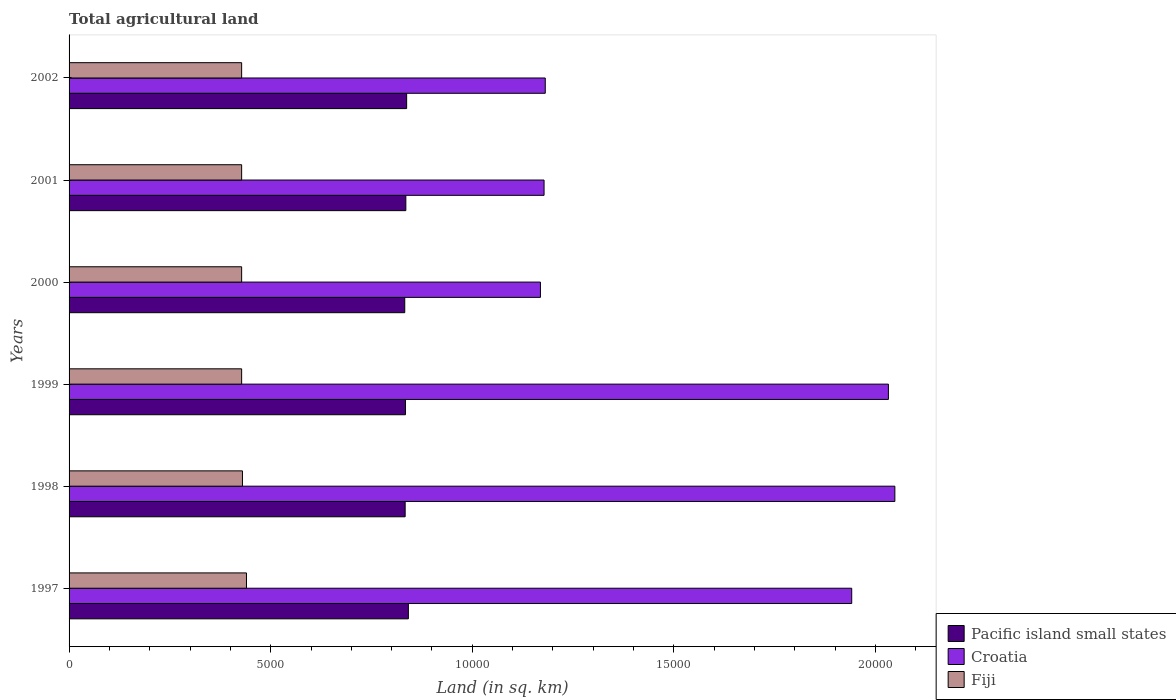How many different coloured bars are there?
Keep it short and to the point. 3. How many groups of bars are there?
Provide a succinct answer. 6. Are the number of bars per tick equal to the number of legend labels?
Make the answer very short. Yes. How many bars are there on the 4th tick from the top?
Your response must be concise. 3. In how many cases, is the number of bars for a given year not equal to the number of legend labels?
Provide a short and direct response. 0. What is the total agricultural land in Fiji in 2002?
Provide a short and direct response. 4280. Across all years, what is the maximum total agricultural land in Fiji?
Your answer should be very brief. 4400. Across all years, what is the minimum total agricultural land in Fiji?
Provide a short and direct response. 4280. What is the total total agricultural land in Croatia in the graph?
Offer a very short reply. 9.55e+04. What is the difference between the total agricultural land in Fiji in 1998 and that in 2001?
Keep it short and to the point. 20. What is the difference between the total agricultural land in Croatia in 2000 and the total agricultural land in Fiji in 2002?
Ensure brevity in your answer.  7410. What is the average total agricultural land in Fiji per year?
Offer a terse response. 4303.33. In the year 1997, what is the difference between the total agricultural land in Fiji and total agricultural land in Pacific island small states?
Provide a short and direct response. -4015. What is the ratio of the total agricultural land in Croatia in 1999 to that in 2001?
Give a very brief answer. 1.72. What is the difference between the highest and the lowest total agricultural land in Pacific island small states?
Keep it short and to the point. 90. What does the 3rd bar from the top in 2000 represents?
Offer a terse response. Pacific island small states. What does the 1st bar from the bottom in 1997 represents?
Keep it short and to the point. Pacific island small states. Is it the case that in every year, the sum of the total agricultural land in Fiji and total agricultural land in Pacific island small states is greater than the total agricultural land in Croatia?
Your answer should be very brief. No. How many years are there in the graph?
Ensure brevity in your answer.  6. What is the difference between two consecutive major ticks on the X-axis?
Ensure brevity in your answer.  5000. Are the values on the major ticks of X-axis written in scientific E-notation?
Your answer should be very brief. No. Does the graph contain any zero values?
Offer a terse response. No. Where does the legend appear in the graph?
Your answer should be very brief. Bottom right. How many legend labels are there?
Provide a short and direct response. 3. How are the legend labels stacked?
Offer a very short reply. Vertical. What is the title of the graph?
Offer a terse response. Total agricultural land. What is the label or title of the X-axis?
Your response must be concise. Land (in sq. km). What is the Land (in sq. km) in Pacific island small states in 1997?
Provide a succinct answer. 8415. What is the Land (in sq. km) of Croatia in 1997?
Provide a succinct answer. 1.94e+04. What is the Land (in sq. km) of Fiji in 1997?
Make the answer very short. 4400. What is the Land (in sq. km) in Pacific island small states in 1998?
Offer a terse response. 8335. What is the Land (in sq. km) of Croatia in 1998?
Offer a terse response. 2.05e+04. What is the Land (in sq. km) of Fiji in 1998?
Your answer should be very brief. 4300. What is the Land (in sq. km) of Pacific island small states in 1999?
Keep it short and to the point. 8343. What is the Land (in sq. km) in Croatia in 1999?
Provide a succinct answer. 2.03e+04. What is the Land (in sq. km) in Fiji in 1999?
Offer a terse response. 4280. What is the Land (in sq. km) in Pacific island small states in 2000?
Give a very brief answer. 8325. What is the Land (in sq. km) of Croatia in 2000?
Make the answer very short. 1.17e+04. What is the Land (in sq. km) in Fiji in 2000?
Give a very brief answer. 4280. What is the Land (in sq. km) of Pacific island small states in 2001?
Provide a succinct answer. 8352. What is the Land (in sq. km) in Croatia in 2001?
Provide a succinct answer. 1.18e+04. What is the Land (in sq. km) of Fiji in 2001?
Ensure brevity in your answer.  4280. What is the Land (in sq. km) in Pacific island small states in 2002?
Your response must be concise. 8372. What is the Land (in sq. km) in Croatia in 2002?
Offer a very short reply. 1.18e+04. What is the Land (in sq. km) of Fiji in 2002?
Provide a short and direct response. 4280. Across all years, what is the maximum Land (in sq. km) of Pacific island small states?
Ensure brevity in your answer.  8415. Across all years, what is the maximum Land (in sq. km) of Croatia?
Your answer should be compact. 2.05e+04. Across all years, what is the maximum Land (in sq. km) of Fiji?
Offer a terse response. 4400. Across all years, what is the minimum Land (in sq. km) in Pacific island small states?
Your response must be concise. 8325. Across all years, what is the minimum Land (in sq. km) of Croatia?
Offer a terse response. 1.17e+04. Across all years, what is the minimum Land (in sq. km) in Fiji?
Keep it short and to the point. 4280. What is the total Land (in sq. km) in Pacific island small states in the graph?
Keep it short and to the point. 5.01e+04. What is the total Land (in sq. km) of Croatia in the graph?
Keep it short and to the point. 9.55e+04. What is the total Land (in sq. km) in Fiji in the graph?
Give a very brief answer. 2.58e+04. What is the difference between the Land (in sq. km) of Croatia in 1997 and that in 1998?
Provide a succinct answer. -1070. What is the difference between the Land (in sq. km) in Pacific island small states in 1997 and that in 1999?
Give a very brief answer. 72. What is the difference between the Land (in sq. km) of Croatia in 1997 and that in 1999?
Your response must be concise. -910. What is the difference between the Land (in sq. km) in Fiji in 1997 and that in 1999?
Provide a short and direct response. 120. What is the difference between the Land (in sq. km) of Croatia in 1997 and that in 2000?
Offer a very short reply. 7720. What is the difference between the Land (in sq. km) of Fiji in 1997 and that in 2000?
Keep it short and to the point. 120. What is the difference between the Land (in sq. km) of Croatia in 1997 and that in 2001?
Your response must be concise. 7630. What is the difference between the Land (in sq. km) of Fiji in 1997 and that in 2001?
Provide a succinct answer. 120. What is the difference between the Land (in sq. km) in Croatia in 1997 and that in 2002?
Offer a very short reply. 7600. What is the difference between the Land (in sq. km) of Fiji in 1997 and that in 2002?
Offer a terse response. 120. What is the difference between the Land (in sq. km) in Croatia in 1998 and that in 1999?
Keep it short and to the point. 160. What is the difference between the Land (in sq. km) in Fiji in 1998 and that in 1999?
Give a very brief answer. 20. What is the difference between the Land (in sq. km) of Pacific island small states in 1998 and that in 2000?
Ensure brevity in your answer.  10. What is the difference between the Land (in sq. km) of Croatia in 1998 and that in 2000?
Your answer should be very brief. 8790. What is the difference between the Land (in sq. km) of Croatia in 1998 and that in 2001?
Provide a short and direct response. 8700. What is the difference between the Land (in sq. km) in Pacific island small states in 1998 and that in 2002?
Keep it short and to the point. -37. What is the difference between the Land (in sq. km) of Croatia in 1998 and that in 2002?
Provide a short and direct response. 8670. What is the difference between the Land (in sq. km) in Pacific island small states in 1999 and that in 2000?
Your answer should be very brief. 18. What is the difference between the Land (in sq. km) in Croatia in 1999 and that in 2000?
Keep it short and to the point. 8630. What is the difference between the Land (in sq. km) in Croatia in 1999 and that in 2001?
Your answer should be compact. 8540. What is the difference between the Land (in sq. km) in Pacific island small states in 1999 and that in 2002?
Offer a terse response. -29. What is the difference between the Land (in sq. km) in Croatia in 1999 and that in 2002?
Your answer should be very brief. 8510. What is the difference between the Land (in sq. km) of Croatia in 2000 and that in 2001?
Offer a terse response. -90. What is the difference between the Land (in sq. km) of Fiji in 2000 and that in 2001?
Offer a terse response. 0. What is the difference between the Land (in sq. km) of Pacific island small states in 2000 and that in 2002?
Your answer should be very brief. -47. What is the difference between the Land (in sq. km) of Croatia in 2000 and that in 2002?
Your answer should be compact. -120. What is the difference between the Land (in sq. km) of Fiji in 2000 and that in 2002?
Give a very brief answer. 0. What is the difference between the Land (in sq. km) of Pacific island small states in 2001 and that in 2002?
Offer a terse response. -20. What is the difference between the Land (in sq. km) in Croatia in 2001 and that in 2002?
Your response must be concise. -30. What is the difference between the Land (in sq. km) of Fiji in 2001 and that in 2002?
Your answer should be compact. 0. What is the difference between the Land (in sq. km) of Pacific island small states in 1997 and the Land (in sq. km) of Croatia in 1998?
Keep it short and to the point. -1.21e+04. What is the difference between the Land (in sq. km) of Pacific island small states in 1997 and the Land (in sq. km) of Fiji in 1998?
Keep it short and to the point. 4115. What is the difference between the Land (in sq. km) of Croatia in 1997 and the Land (in sq. km) of Fiji in 1998?
Provide a succinct answer. 1.51e+04. What is the difference between the Land (in sq. km) of Pacific island small states in 1997 and the Land (in sq. km) of Croatia in 1999?
Keep it short and to the point. -1.19e+04. What is the difference between the Land (in sq. km) of Pacific island small states in 1997 and the Land (in sq. km) of Fiji in 1999?
Offer a very short reply. 4135. What is the difference between the Land (in sq. km) of Croatia in 1997 and the Land (in sq. km) of Fiji in 1999?
Make the answer very short. 1.51e+04. What is the difference between the Land (in sq. km) in Pacific island small states in 1997 and the Land (in sq. km) in Croatia in 2000?
Keep it short and to the point. -3275. What is the difference between the Land (in sq. km) of Pacific island small states in 1997 and the Land (in sq. km) of Fiji in 2000?
Provide a succinct answer. 4135. What is the difference between the Land (in sq. km) in Croatia in 1997 and the Land (in sq. km) in Fiji in 2000?
Ensure brevity in your answer.  1.51e+04. What is the difference between the Land (in sq. km) of Pacific island small states in 1997 and the Land (in sq. km) of Croatia in 2001?
Give a very brief answer. -3365. What is the difference between the Land (in sq. km) of Pacific island small states in 1997 and the Land (in sq. km) of Fiji in 2001?
Keep it short and to the point. 4135. What is the difference between the Land (in sq. km) of Croatia in 1997 and the Land (in sq. km) of Fiji in 2001?
Your answer should be compact. 1.51e+04. What is the difference between the Land (in sq. km) in Pacific island small states in 1997 and the Land (in sq. km) in Croatia in 2002?
Ensure brevity in your answer.  -3395. What is the difference between the Land (in sq. km) of Pacific island small states in 1997 and the Land (in sq. km) of Fiji in 2002?
Ensure brevity in your answer.  4135. What is the difference between the Land (in sq. km) in Croatia in 1997 and the Land (in sq. km) in Fiji in 2002?
Keep it short and to the point. 1.51e+04. What is the difference between the Land (in sq. km) in Pacific island small states in 1998 and the Land (in sq. km) in Croatia in 1999?
Your answer should be very brief. -1.20e+04. What is the difference between the Land (in sq. km) in Pacific island small states in 1998 and the Land (in sq. km) in Fiji in 1999?
Provide a short and direct response. 4055. What is the difference between the Land (in sq. km) of Croatia in 1998 and the Land (in sq. km) of Fiji in 1999?
Offer a very short reply. 1.62e+04. What is the difference between the Land (in sq. km) of Pacific island small states in 1998 and the Land (in sq. km) of Croatia in 2000?
Give a very brief answer. -3355. What is the difference between the Land (in sq. km) in Pacific island small states in 1998 and the Land (in sq. km) in Fiji in 2000?
Make the answer very short. 4055. What is the difference between the Land (in sq. km) in Croatia in 1998 and the Land (in sq. km) in Fiji in 2000?
Make the answer very short. 1.62e+04. What is the difference between the Land (in sq. km) in Pacific island small states in 1998 and the Land (in sq. km) in Croatia in 2001?
Your answer should be compact. -3445. What is the difference between the Land (in sq. km) of Pacific island small states in 1998 and the Land (in sq. km) of Fiji in 2001?
Make the answer very short. 4055. What is the difference between the Land (in sq. km) of Croatia in 1998 and the Land (in sq. km) of Fiji in 2001?
Give a very brief answer. 1.62e+04. What is the difference between the Land (in sq. km) in Pacific island small states in 1998 and the Land (in sq. km) in Croatia in 2002?
Your answer should be very brief. -3475. What is the difference between the Land (in sq. km) of Pacific island small states in 1998 and the Land (in sq. km) of Fiji in 2002?
Provide a succinct answer. 4055. What is the difference between the Land (in sq. km) of Croatia in 1998 and the Land (in sq. km) of Fiji in 2002?
Give a very brief answer. 1.62e+04. What is the difference between the Land (in sq. km) in Pacific island small states in 1999 and the Land (in sq. km) in Croatia in 2000?
Your answer should be compact. -3347. What is the difference between the Land (in sq. km) of Pacific island small states in 1999 and the Land (in sq. km) of Fiji in 2000?
Your answer should be compact. 4063. What is the difference between the Land (in sq. km) in Croatia in 1999 and the Land (in sq. km) in Fiji in 2000?
Your answer should be compact. 1.60e+04. What is the difference between the Land (in sq. km) in Pacific island small states in 1999 and the Land (in sq. km) in Croatia in 2001?
Make the answer very short. -3437. What is the difference between the Land (in sq. km) of Pacific island small states in 1999 and the Land (in sq. km) of Fiji in 2001?
Provide a short and direct response. 4063. What is the difference between the Land (in sq. km) of Croatia in 1999 and the Land (in sq. km) of Fiji in 2001?
Provide a succinct answer. 1.60e+04. What is the difference between the Land (in sq. km) of Pacific island small states in 1999 and the Land (in sq. km) of Croatia in 2002?
Your response must be concise. -3467. What is the difference between the Land (in sq. km) in Pacific island small states in 1999 and the Land (in sq. km) in Fiji in 2002?
Your answer should be compact. 4063. What is the difference between the Land (in sq. km) in Croatia in 1999 and the Land (in sq. km) in Fiji in 2002?
Offer a very short reply. 1.60e+04. What is the difference between the Land (in sq. km) in Pacific island small states in 2000 and the Land (in sq. km) in Croatia in 2001?
Offer a terse response. -3455. What is the difference between the Land (in sq. km) in Pacific island small states in 2000 and the Land (in sq. km) in Fiji in 2001?
Provide a succinct answer. 4045. What is the difference between the Land (in sq. km) in Croatia in 2000 and the Land (in sq. km) in Fiji in 2001?
Provide a short and direct response. 7410. What is the difference between the Land (in sq. km) of Pacific island small states in 2000 and the Land (in sq. km) of Croatia in 2002?
Your answer should be very brief. -3485. What is the difference between the Land (in sq. km) in Pacific island small states in 2000 and the Land (in sq. km) in Fiji in 2002?
Make the answer very short. 4045. What is the difference between the Land (in sq. km) in Croatia in 2000 and the Land (in sq. km) in Fiji in 2002?
Ensure brevity in your answer.  7410. What is the difference between the Land (in sq. km) in Pacific island small states in 2001 and the Land (in sq. km) in Croatia in 2002?
Offer a very short reply. -3458. What is the difference between the Land (in sq. km) of Pacific island small states in 2001 and the Land (in sq. km) of Fiji in 2002?
Provide a short and direct response. 4072. What is the difference between the Land (in sq. km) of Croatia in 2001 and the Land (in sq. km) of Fiji in 2002?
Offer a very short reply. 7500. What is the average Land (in sq. km) in Pacific island small states per year?
Provide a succinct answer. 8357. What is the average Land (in sq. km) in Croatia per year?
Provide a short and direct response. 1.59e+04. What is the average Land (in sq. km) of Fiji per year?
Your answer should be compact. 4303.33. In the year 1997, what is the difference between the Land (in sq. km) in Pacific island small states and Land (in sq. km) in Croatia?
Offer a terse response. -1.10e+04. In the year 1997, what is the difference between the Land (in sq. km) of Pacific island small states and Land (in sq. km) of Fiji?
Your answer should be very brief. 4015. In the year 1997, what is the difference between the Land (in sq. km) of Croatia and Land (in sq. km) of Fiji?
Give a very brief answer. 1.50e+04. In the year 1998, what is the difference between the Land (in sq. km) of Pacific island small states and Land (in sq. km) of Croatia?
Provide a succinct answer. -1.21e+04. In the year 1998, what is the difference between the Land (in sq. km) of Pacific island small states and Land (in sq. km) of Fiji?
Your answer should be very brief. 4035. In the year 1998, what is the difference between the Land (in sq. km) of Croatia and Land (in sq. km) of Fiji?
Provide a succinct answer. 1.62e+04. In the year 1999, what is the difference between the Land (in sq. km) of Pacific island small states and Land (in sq. km) of Croatia?
Your answer should be compact. -1.20e+04. In the year 1999, what is the difference between the Land (in sq. km) of Pacific island small states and Land (in sq. km) of Fiji?
Ensure brevity in your answer.  4063. In the year 1999, what is the difference between the Land (in sq. km) in Croatia and Land (in sq. km) in Fiji?
Provide a short and direct response. 1.60e+04. In the year 2000, what is the difference between the Land (in sq. km) of Pacific island small states and Land (in sq. km) of Croatia?
Provide a short and direct response. -3365. In the year 2000, what is the difference between the Land (in sq. km) in Pacific island small states and Land (in sq. km) in Fiji?
Ensure brevity in your answer.  4045. In the year 2000, what is the difference between the Land (in sq. km) in Croatia and Land (in sq. km) in Fiji?
Provide a succinct answer. 7410. In the year 2001, what is the difference between the Land (in sq. km) of Pacific island small states and Land (in sq. km) of Croatia?
Give a very brief answer. -3428. In the year 2001, what is the difference between the Land (in sq. km) of Pacific island small states and Land (in sq. km) of Fiji?
Give a very brief answer. 4072. In the year 2001, what is the difference between the Land (in sq. km) of Croatia and Land (in sq. km) of Fiji?
Provide a short and direct response. 7500. In the year 2002, what is the difference between the Land (in sq. km) of Pacific island small states and Land (in sq. km) of Croatia?
Give a very brief answer. -3438. In the year 2002, what is the difference between the Land (in sq. km) of Pacific island small states and Land (in sq. km) of Fiji?
Make the answer very short. 4092. In the year 2002, what is the difference between the Land (in sq. km) in Croatia and Land (in sq. km) in Fiji?
Offer a very short reply. 7530. What is the ratio of the Land (in sq. km) of Pacific island small states in 1997 to that in 1998?
Your response must be concise. 1.01. What is the ratio of the Land (in sq. km) of Croatia in 1997 to that in 1998?
Make the answer very short. 0.95. What is the ratio of the Land (in sq. km) in Fiji in 1997 to that in 1998?
Keep it short and to the point. 1.02. What is the ratio of the Land (in sq. km) in Pacific island small states in 1997 to that in 1999?
Your answer should be very brief. 1.01. What is the ratio of the Land (in sq. km) in Croatia in 1997 to that in 1999?
Provide a succinct answer. 0.96. What is the ratio of the Land (in sq. km) of Fiji in 1997 to that in 1999?
Offer a very short reply. 1.03. What is the ratio of the Land (in sq. km) in Pacific island small states in 1997 to that in 2000?
Your answer should be very brief. 1.01. What is the ratio of the Land (in sq. km) of Croatia in 1997 to that in 2000?
Provide a succinct answer. 1.66. What is the ratio of the Land (in sq. km) in Fiji in 1997 to that in 2000?
Give a very brief answer. 1.03. What is the ratio of the Land (in sq. km) of Pacific island small states in 1997 to that in 2001?
Give a very brief answer. 1.01. What is the ratio of the Land (in sq. km) of Croatia in 1997 to that in 2001?
Your response must be concise. 1.65. What is the ratio of the Land (in sq. km) in Fiji in 1997 to that in 2001?
Make the answer very short. 1.03. What is the ratio of the Land (in sq. km) in Pacific island small states in 1997 to that in 2002?
Provide a short and direct response. 1.01. What is the ratio of the Land (in sq. km) of Croatia in 1997 to that in 2002?
Give a very brief answer. 1.64. What is the ratio of the Land (in sq. km) in Fiji in 1997 to that in 2002?
Your response must be concise. 1.03. What is the ratio of the Land (in sq. km) of Croatia in 1998 to that in 1999?
Provide a succinct answer. 1.01. What is the ratio of the Land (in sq. km) of Croatia in 1998 to that in 2000?
Your response must be concise. 1.75. What is the ratio of the Land (in sq. km) in Fiji in 1998 to that in 2000?
Your answer should be compact. 1. What is the ratio of the Land (in sq. km) of Pacific island small states in 1998 to that in 2001?
Your answer should be very brief. 1. What is the ratio of the Land (in sq. km) of Croatia in 1998 to that in 2001?
Your answer should be very brief. 1.74. What is the ratio of the Land (in sq. km) of Croatia in 1998 to that in 2002?
Your answer should be very brief. 1.73. What is the ratio of the Land (in sq. km) of Fiji in 1998 to that in 2002?
Provide a short and direct response. 1. What is the ratio of the Land (in sq. km) of Pacific island small states in 1999 to that in 2000?
Ensure brevity in your answer.  1. What is the ratio of the Land (in sq. km) in Croatia in 1999 to that in 2000?
Provide a succinct answer. 1.74. What is the ratio of the Land (in sq. km) in Fiji in 1999 to that in 2000?
Keep it short and to the point. 1. What is the ratio of the Land (in sq. km) of Pacific island small states in 1999 to that in 2001?
Make the answer very short. 1. What is the ratio of the Land (in sq. km) of Croatia in 1999 to that in 2001?
Ensure brevity in your answer.  1.73. What is the ratio of the Land (in sq. km) of Croatia in 1999 to that in 2002?
Your answer should be compact. 1.72. What is the ratio of the Land (in sq. km) in Pacific island small states in 2000 to that in 2002?
Offer a terse response. 0.99. What is the ratio of the Land (in sq. km) in Fiji in 2000 to that in 2002?
Your answer should be compact. 1. What is the ratio of the Land (in sq. km) of Croatia in 2001 to that in 2002?
Offer a very short reply. 1. What is the ratio of the Land (in sq. km) in Fiji in 2001 to that in 2002?
Your answer should be very brief. 1. What is the difference between the highest and the second highest Land (in sq. km) in Croatia?
Provide a short and direct response. 160. What is the difference between the highest and the second highest Land (in sq. km) in Fiji?
Your answer should be compact. 100. What is the difference between the highest and the lowest Land (in sq. km) of Pacific island small states?
Provide a short and direct response. 90. What is the difference between the highest and the lowest Land (in sq. km) in Croatia?
Your answer should be very brief. 8790. What is the difference between the highest and the lowest Land (in sq. km) in Fiji?
Ensure brevity in your answer.  120. 